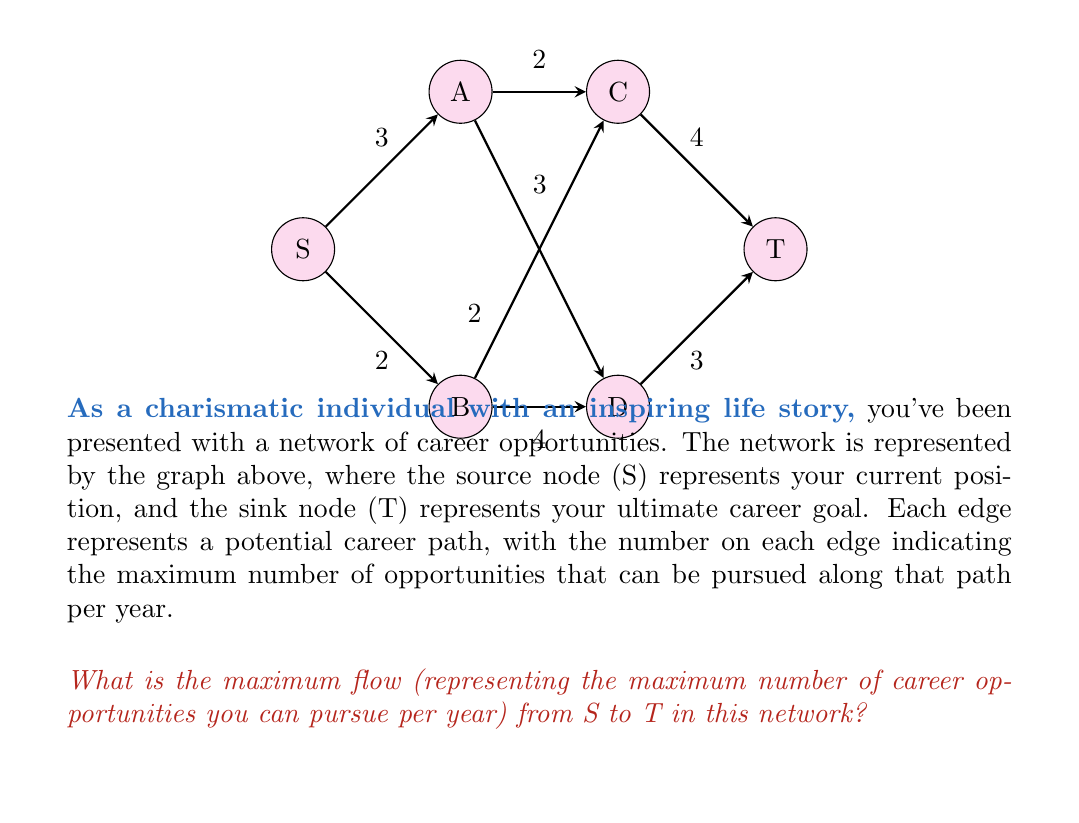Help me with this question. To solve this maximum flow problem, we'll use the Ford-Fulkerson algorithm:

1) Initialize flow to 0 for all edges.

2) Find an augmenting path from S to T:
   Path 1: S → A → C → T (min capacity = 2)
   Increase flow by 2. New flow: 2

3) Find another augmenting path:
   Path 2: S → B → D → T (min capacity = 2)
   Increase flow by 2. New flow: 4

4) Find another augmenting path:
   Path 3: S → A → D → T (min capacity = 1)
   Increase flow by 1. New flow: 5

5) Find another augmenting path:
   Path 4: S → B → C → T (min capacity = 1)
   Increase flow by 1. New flow: 6

6) No more augmenting paths exist. The algorithm terminates.

The maximum flow is the sum of all flows: 2 + 2 + 1 + 1 = 6.

This can be verified by looking at the cut (S, {A,B,C,D,T}), which has a capacity of 3 + 3 = 6, matching our max flow result.
Answer: 6 opportunities per year 